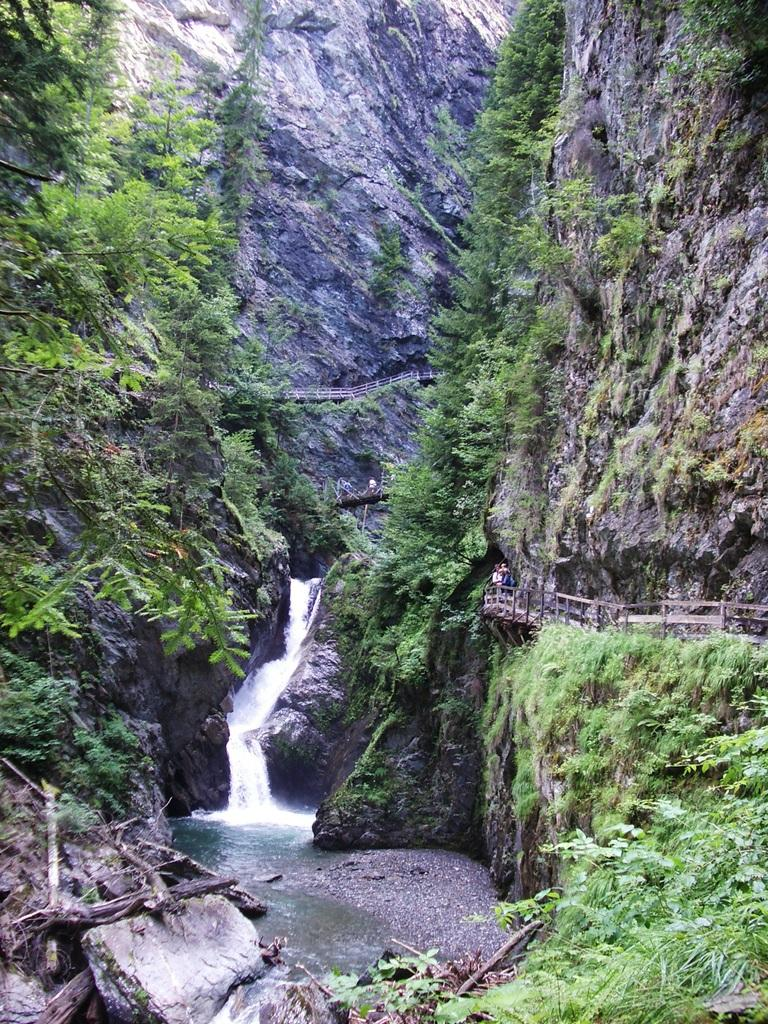What type of natural formation can be seen in the image? There are mountains in the image. What type of vegetation is present in the image? There are trees and plants in the image. What are the persons in the image doing? The persons are standing on a bridge in the image. What is the water doing in the image? There is a water flow between the mountains in the image. What type of belief is being expressed by the mountains in the image? The mountains do not express any beliefs; they are a natural formation. Can you see any wings on the trees in the image? There are no wings present on the trees in the image; they are simply trees. 